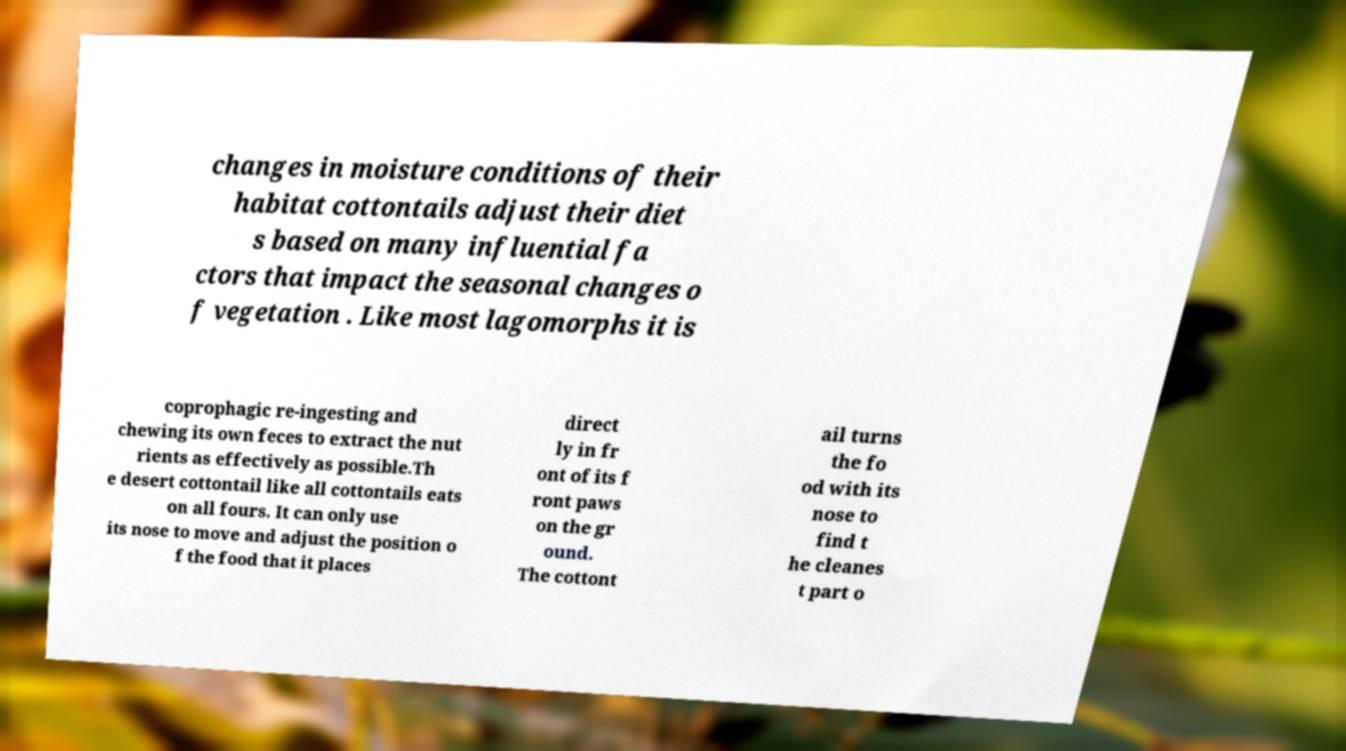For documentation purposes, I need the text within this image transcribed. Could you provide that? changes in moisture conditions of their habitat cottontails adjust their diet s based on many influential fa ctors that impact the seasonal changes o f vegetation . Like most lagomorphs it is coprophagic re-ingesting and chewing its own feces to extract the nut rients as effectively as possible.Th e desert cottontail like all cottontails eats on all fours. It can only use its nose to move and adjust the position o f the food that it places direct ly in fr ont of its f ront paws on the gr ound. The cottont ail turns the fo od with its nose to find t he cleanes t part o 